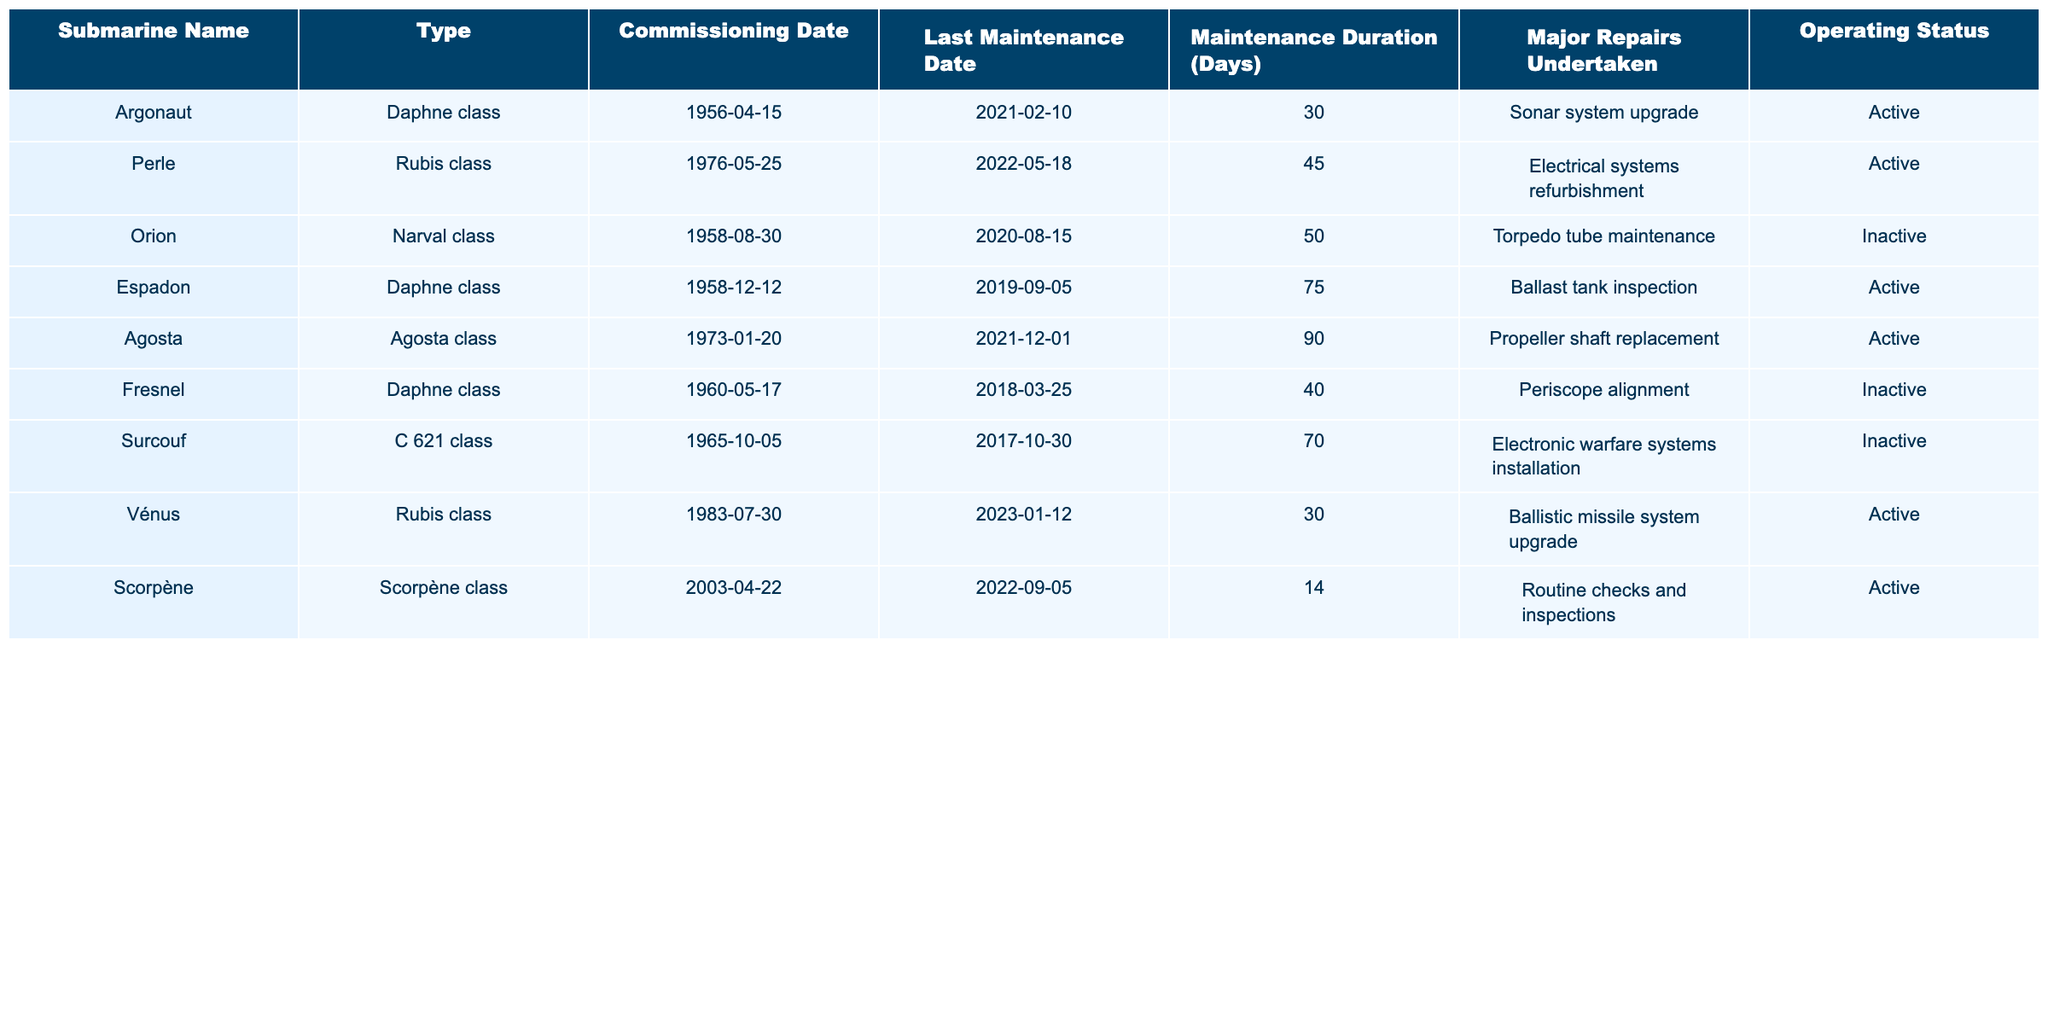What is the name of the submarine that underwent electrical systems refurbishment? The table lists the submarine names and their corresponding maintenance details. By examining the "Major Repairs Undertaken" column, the submarine "Perle" is associated with electrical systems refurbishment.
Answer: Perle How many days did the "Agosta" submarine remain in maintenance? According to the "Maintenance Duration (Days)" column, "Agosta" was in maintenance for 90 days.
Answer: 90 days Is the "Orion" submarine currently active? By looking at the "Operating Status" column, "Orion" is listed as "Inactive," meaning it is not currently active.
Answer: No Which submarine had the longest maintenance duration? By analyzing the "Maintenance Duration (Days)" column, "Agosta" has a maintenance duration of 90 days, which is longer than all other submarines listed.
Answer: Agosta How many submarines are listed as active? By counting the entries in the "Operating Status" column, "Argonaut", "Perle", "Espadon", "Agosta", "Vénus", and "Scorpène" are marked "Active," totaling to 6 submarines.
Answer: 6 submarines What is the average maintenance duration of all submarines listed? First, add the maintenance durations: 30 + 45 + 50 + 75 + 90 + 40 + 70 + 30 + 14 = 404 days. Then, divide by the total number of submarines (9), which results in an average of 404/9 ≈ 44.89 days.
Answer: Approximately 44.89 days What major repairs did the "Fresnel" submarine undergo? Referring to the "Major Repairs Undertaken" column, "Fresnel" had "Periscope alignment" as the major repair performed.
Answer: Periscope alignment Which submarine was commissioned first and what is its status? "Orion" was commissioned on 1958-08-30, and by checking the "Operating Status" column, it is currently "Inactive."
Answer: Inactive Did any submarines have a maintenance duration of less than 30 days? By reviewing the "Maintenance Duration (Days)" column, the durations are 30, 45, 50, 75, 90, 40, 70, 30, and 14 days. Since 14 days is less than 30, the answer is yes.
Answer: Yes Are there any submarines in the "Rubis" class that are currently active? The entry for "Perle" and "Vénus" in the "Type" column shows they belong to the "Rubis" class. Checking the "Operating Status" reveals that both are listed as "Active."
Answer: Yes, two submarines What major repair was done to the "Espadon"? By looking at the "Major Repairs Undertaken" column for "Espadon," it states "Ballast tank inspection" was performed.
Answer: Ballast tank inspection 